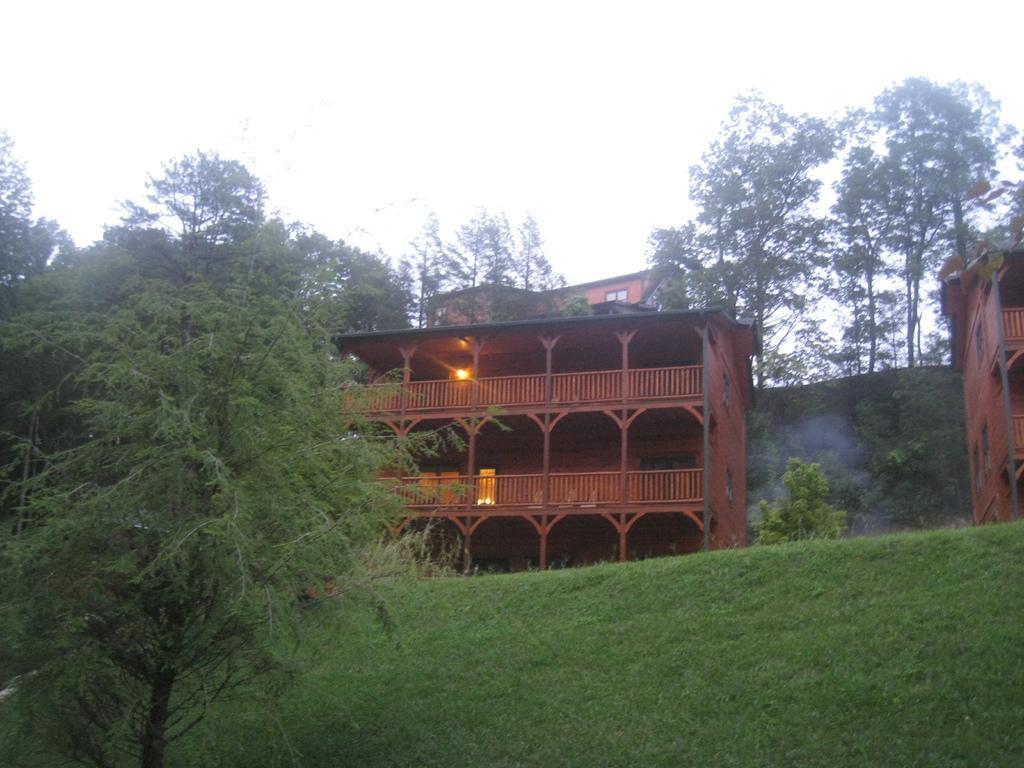How would you summarize this image in a sentence or two? In this image we can see buildings, electric lights, trees, hills and sky. 